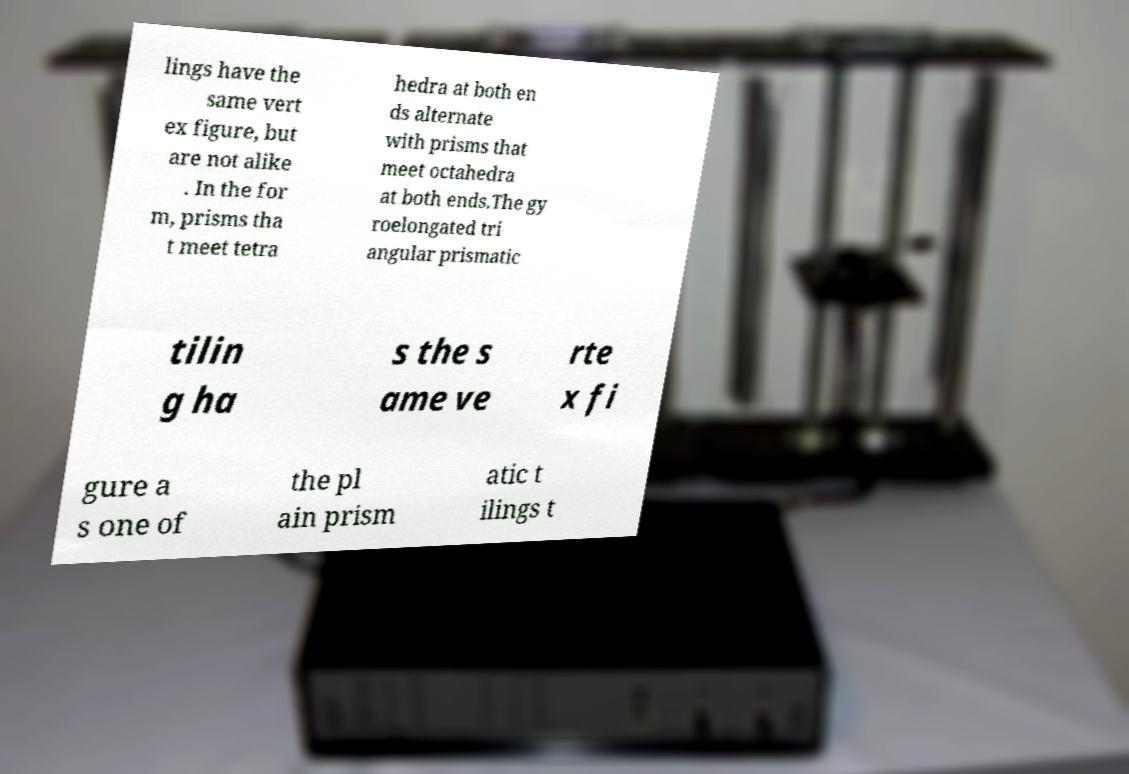Can you accurately transcribe the text from the provided image for me? lings have the same vert ex figure, but are not alike . In the for m, prisms tha t meet tetra hedra at both en ds alternate with prisms that meet octahedra at both ends.The gy roelongated tri angular prismatic tilin g ha s the s ame ve rte x fi gure a s one of the pl ain prism atic t ilings t 